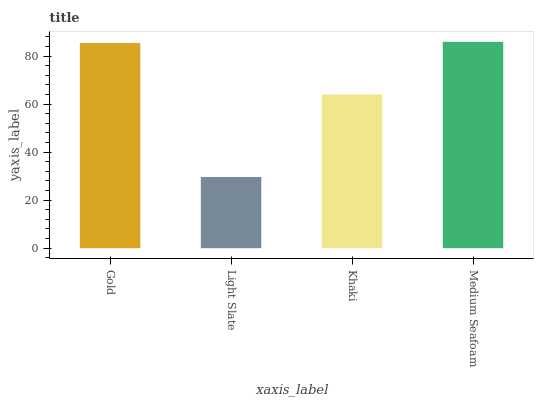Is Light Slate the minimum?
Answer yes or no. Yes. Is Medium Seafoam the maximum?
Answer yes or no. Yes. Is Khaki the minimum?
Answer yes or no. No. Is Khaki the maximum?
Answer yes or no. No. Is Khaki greater than Light Slate?
Answer yes or no. Yes. Is Light Slate less than Khaki?
Answer yes or no. Yes. Is Light Slate greater than Khaki?
Answer yes or no. No. Is Khaki less than Light Slate?
Answer yes or no. No. Is Gold the high median?
Answer yes or no. Yes. Is Khaki the low median?
Answer yes or no. Yes. Is Khaki the high median?
Answer yes or no. No. Is Medium Seafoam the low median?
Answer yes or no. No. 